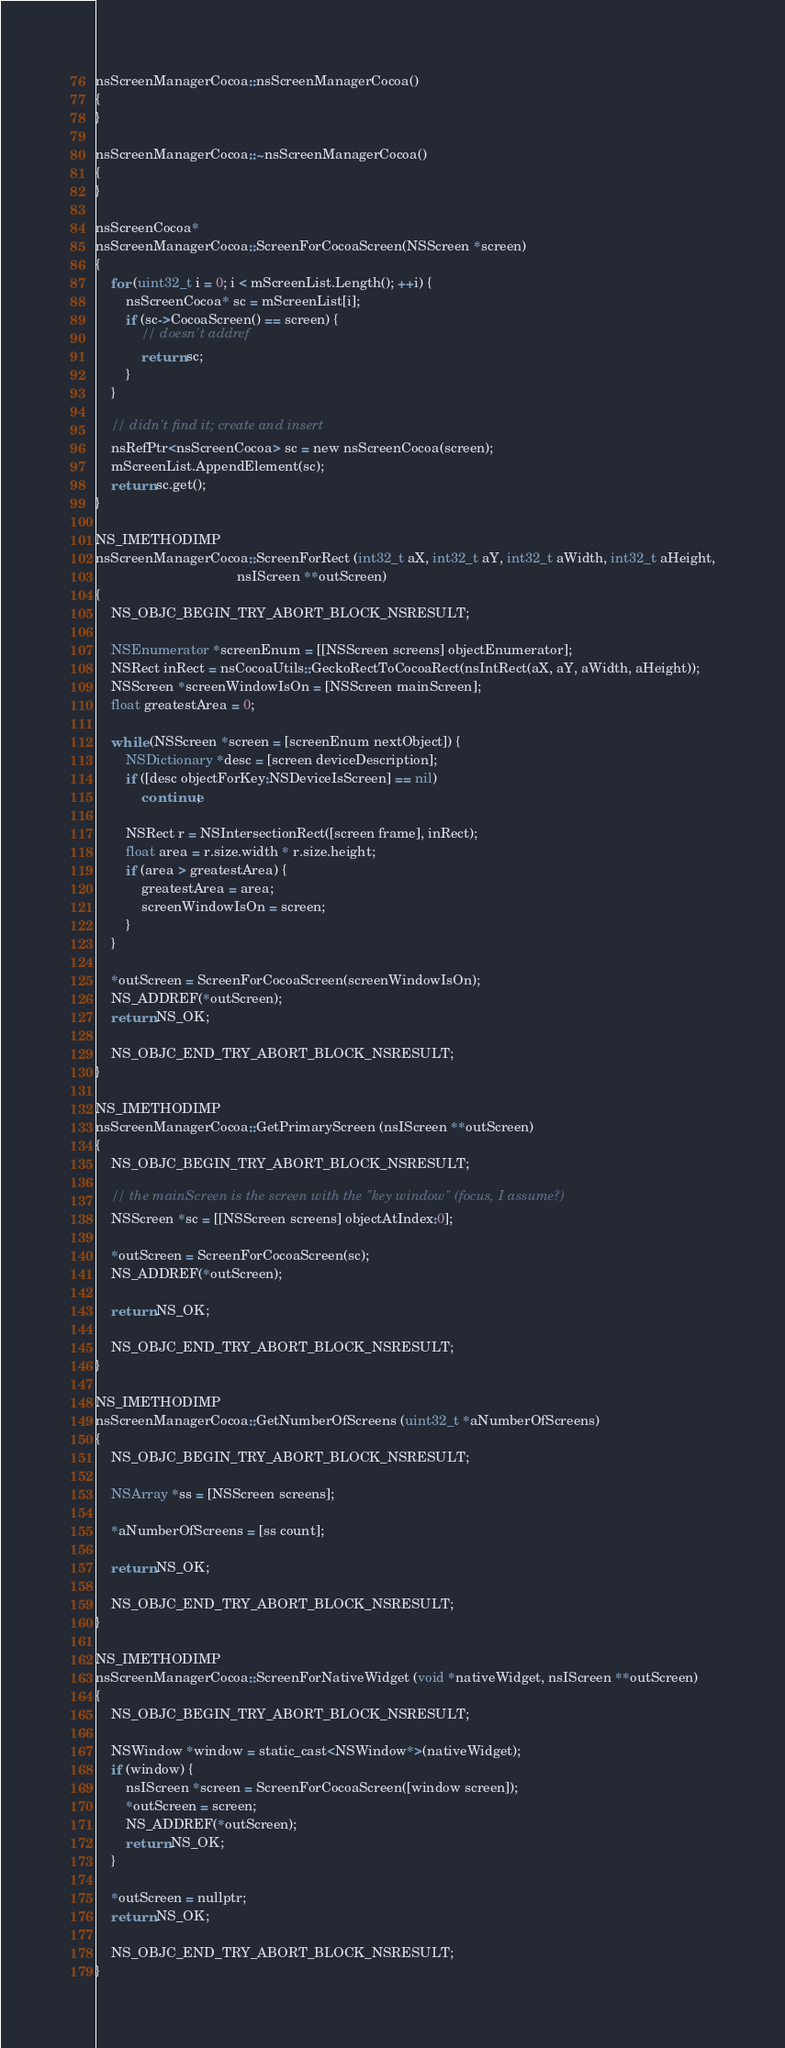Convert code to text. <code><loc_0><loc_0><loc_500><loc_500><_ObjectiveC_>
nsScreenManagerCocoa::nsScreenManagerCocoa()
{
}

nsScreenManagerCocoa::~nsScreenManagerCocoa()
{
}

nsScreenCocoa*
nsScreenManagerCocoa::ScreenForCocoaScreen(NSScreen *screen)
{
    for (uint32_t i = 0; i < mScreenList.Length(); ++i) {
        nsScreenCocoa* sc = mScreenList[i];
        if (sc->CocoaScreen() == screen) {
            // doesn't addref
            return sc;
        }
    }

    // didn't find it; create and insert
    nsRefPtr<nsScreenCocoa> sc = new nsScreenCocoa(screen);
    mScreenList.AppendElement(sc);
    return sc.get();
}

NS_IMETHODIMP
nsScreenManagerCocoa::ScreenForRect (int32_t aX, int32_t aY, int32_t aWidth, int32_t aHeight,
                                     nsIScreen **outScreen)
{
    NS_OBJC_BEGIN_TRY_ABORT_BLOCK_NSRESULT;

    NSEnumerator *screenEnum = [[NSScreen screens] objectEnumerator];
    NSRect inRect = nsCocoaUtils::GeckoRectToCocoaRect(nsIntRect(aX, aY, aWidth, aHeight));
    NSScreen *screenWindowIsOn = [NSScreen mainScreen];
    float greatestArea = 0;

    while (NSScreen *screen = [screenEnum nextObject]) {
        NSDictionary *desc = [screen deviceDescription];
        if ([desc objectForKey:NSDeviceIsScreen] == nil)
            continue;

        NSRect r = NSIntersectionRect([screen frame], inRect);
        float area = r.size.width * r.size.height;
        if (area > greatestArea) {
            greatestArea = area;
            screenWindowIsOn = screen;
        }
    }

    *outScreen = ScreenForCocoaScreen(screenWindowIsOn);
    NS_ADDREF(*outScreen);
    return NS_OK;

    NS_OBJC_END_TRY_ABORT_BLOCK_NSRESULT;
}

NS_IMETHODIMP
nsScreenManagerCocoa::GetPrimaryScreen (nsIScreen **outScreen)
{
    NS_OBJC_BEGIN_TRY_ABORT_BLOCK_NSRESULT;

    // the mainScreen is the screen with the "key window" (focus, I assume?)
    NSScreen *sc = [[NSScreen screens] objectAtIndex:0];

    *outScreen = ScreenForCocoaScreen(sc);
    NS_ADDREF(*outScreen);

    return NS_OK;

    NS_OBJC_END_TRY_ABORT_BLOCK_NSRESULT;
}

NS_IMETHODIMP
nsScreenManagerCocoa::GetNumberOfScreens (uint32_t *aNumberOfScreens)
{
    NS_OBJC_BEGIN_TRY_ABORT_BLOCK_NSRESULT;

    NSArray *ss = [NSScreen screens];

    *aNumberOfScreens = [ss count];

    return NS_OK;

    NS_OBJC_END_TRY_ABORT_BLOCK_NSRESULT;
}

NS_IMETHODIMP
nsScreenManagerCocoa::ScreenForNativeWidget (void *nativeWidget, nsIScreen **outScreen)
{
    NS_OBJC_BEGIN_TRY_ABORT_BLOCK_NSRESULT;

    NSWindow *window = static_cast<NSWindow*>(nativeWidget);
    if (window) {
        nsIScreen *screen = ScreenForCocoaScreen([window screen]);
        *outScreen = screen;
        NS_ADDREF(*outScreen);
        return NS_OK;
    }

    *outScreen = nullptr;
    return NS_OK;

    NS_OBJC_END_TRY_ABORT_BLOCK_NSRESULT;
}
</code> 